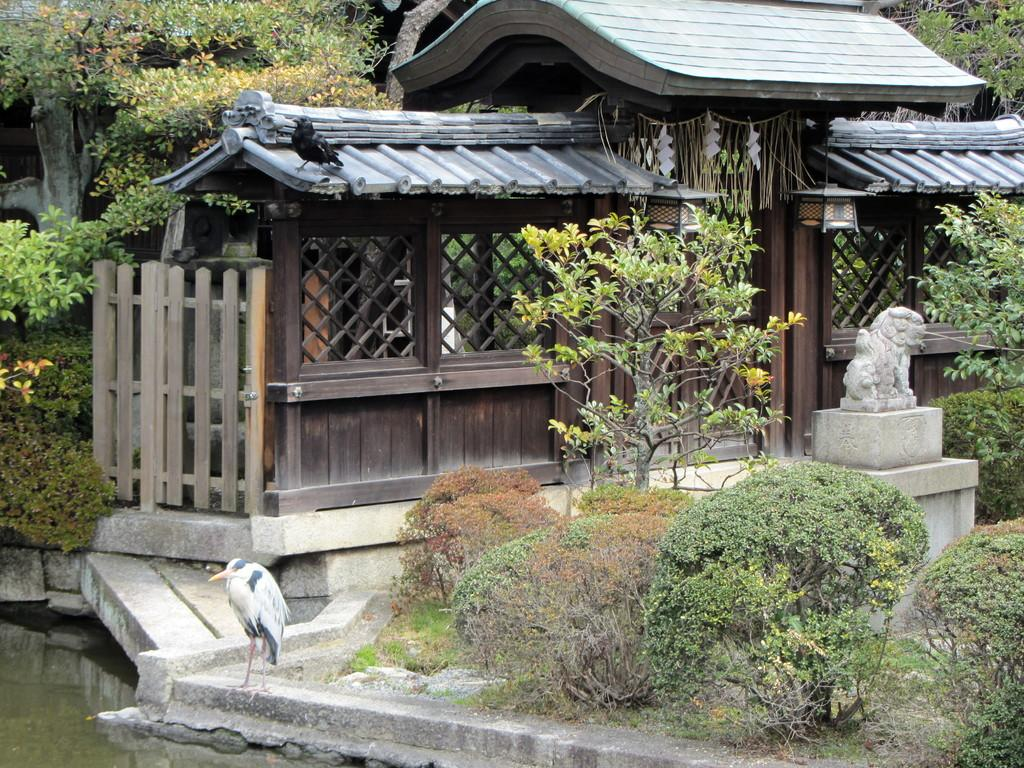What type of house is in the center of the image? There is a wooden house in the center of the image. What animals can be seen in the image? Birds are visible in the image. What type of vegetation is present in the image? There are trees and plants in the image. What is at the bottom of the image? There is water at the bottom of the image. How many fish can be seen swimming in the water at the bottom of the image? There are no fish visible in the image; only water is present at the bottom. 